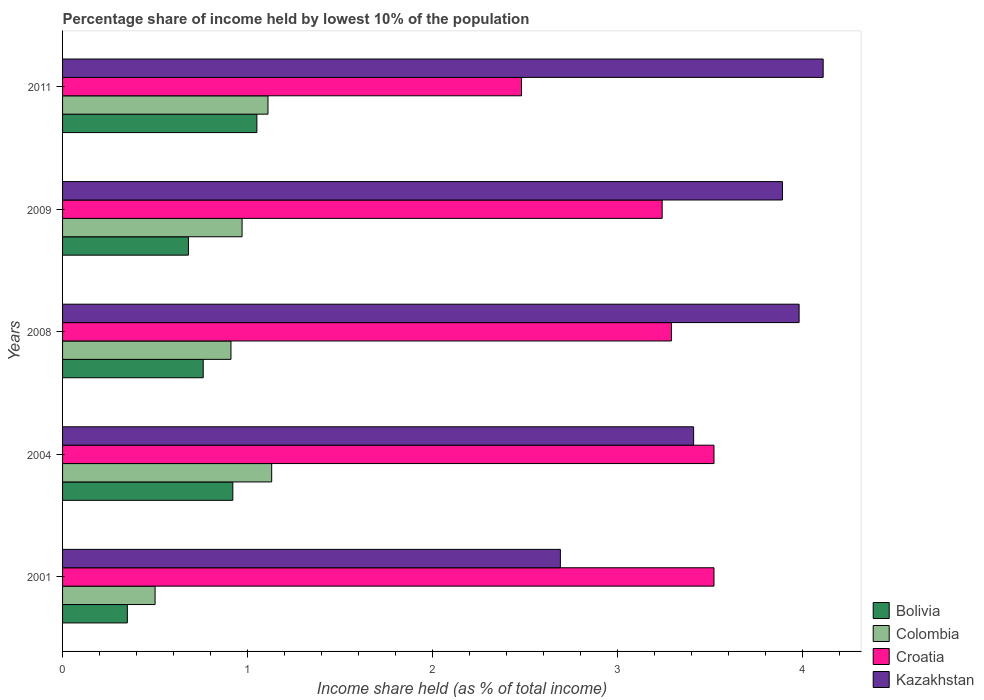How many different coloured bars are there?
Your answer should be very brief. 4. How many groups of bars are there?
Offer a terse response. 5. Are the number of bars on each tick of the Y-axis equal?
Your answer should be compact. Yes. How many bars are there on the 1st tick from the top?
Provide a short and direct response. 4. How many bars are there on the 2nd tick from the bottom?
Provide a succinct answer. 4. What is the label of the 5th group of bars from the top?
Your answer should be compact. 2001. In how many cases, is the number of bars for a given year not equal to the number of legend labels?
Keep it short and to the point. 0. Across all years, what is the minimum percentage share of income held by lowest 10% of the population in Kazakhstan?
Ensure brevity in your answer.  2.69. In which year was the percentage share of income held by lowest 10% of the population in Bolivia maximum?
Offer a terse response. 2011. In which year was the percentage share of income held by lowest 10% of the population in Colombia minimum?
Your answer should be compact. 2001. What is the total percentage share of income held by lowest 10% of the population in Bolivia in the graph?
Make the answer very short. 3.76. What is the difference between the percentage share of income held by lowest 10% of the population in Croatia in 2004 and that in 2009?
Offer a very short reply. 0.28. What is the difference between the percentage share of income held by lowest 10% of the population in Colombia in 2009 and the percentage share of income held by lowest 10% of the population in Kazakhstan in 2008?
Make the answer very short. -3.01. What is the average percentage share of income held by lowest 10% of the population in Kazakhstan per year?
Make the answer very short. 3.62. In the year 2011, what is the difference between the percentage share of income held by lowest 10% of the population in Croatia and percentage share of income held by lowest 10% of the population in Colombia?
Give a very brief answer. 1.37. What is the ratio of the percentage share of income held by lowest 10% of the population in Bolivia in 2004 to that in 2009?
Your answer should be very brief. 1.35. Is the percentage share of income held by lowest 10% of the population in Colombia in 2004 less than that in 2008?
Provide a succinct answer. No. Is the difference between the percentage share of income held by lowest 10% of the population in Croatia in 2001 and 2008 greater than the difference between the percentage share of income held by lowest 10% of the population in Colombia in 2001 and 2008?
Keep it short and to the point. Yes. What is the difference between the highest and the lowest percentage share of income held by lowest 10% of the population in Kazakhstan?
Your answer should be compact. 1.42. Is it the case that in every year, the sum of the percentage share of income held by lowest 10% of the population in Croatia and percentage share of income held by lowest 10% of the population in Bolivia is greater than the sum of percentage share of income held by lowest 10% of the population in Kazakhstan and percentage share of income held by lowest 10% of the population in Colombia?
Make the answer very short. Yes. What does the 4th bar from the top in 2001 represents?
Your answer should be compact. Bolivia. What does the 4th bar from the bottom in 2004 represents?
Offer a very short reply. Kazakhstan. Is it the case that in every year, the sum of the percentage share of income held by lowest 10% of the population in Croatia and percentage share of income held by lowest 10% of the population in Colombia is greater than the percentage share of income held by lowest 10% of the population in Kazakhstan?
Provide a short and direct response. No. Does the graph contain any zero values?
Make the answer very short. No. How many legend labels are there?
Offer a very short reply. 4. What is the title of the graph?
Make the answer very short. Percentage share of income held by lowest 10% of the population. What is the label or title of the X-axis?
Provide a succinct answer. Income share held (as % of total income). What is the label or title of the Y-axis?
Your answer should be compact. Years. What is the Income share held (as % of total income) of Croatia in 2001?
Offer a terse response. 3.52. What is the Income share held (as % of total income) in Kazakhstan in 2001?
Keep it short and to the point. 2.69. What is the Income share held (as % of total income) of Bolivia in 2004?
Keep it short and to the point. 0.92. What is the Income share held (as % of total income) in Colombia in 2004?
Your answer should be very brief. 1.13. What is the Income share held (as % of total income) in Croatia in 2004?
Provide a succinct answer. 3.52. What is the Income share held (as % of total income) of Kazakhstan in 2004?
Your response must be concise. 3.41. What is the Income share held (as % of total income) of Bolivia in 2008?
Provide a short and direct response. 0.76. What is the Income share held (as % of total income) in Colombia in 2008?
Your answer should be very brief. 0.91. What is the Income share held (as % of total income) of Croatia in 2008?
Ensure brevity in your answer.  3.29. What is the Income share held (as % of total income) in Kazakhstan in 2008?
Your response must be concise. 3.98. What is the Income share held (as % of total income) of Bolivia in 2009?
Your answer should be very brief. 0.68. What is the Income share held (as % of total income) of Colombia in 2009?
Your answer should be compact. 0.97. What is the Income share held (as % of total income) of Croatia in 2009?
Offer a very short reply. 3.24. What is the Income share held (as % of total income) in Kazakhstan in 2009?
Make the answer very short. 3.89. What is the Income share held (as % of total income) in Colombia in 2011?
Ensure brevity in your answer.  1.11. What is the Income share held (as % of total income) of Croatia in 2011?
Your answer should be compact. 2.48. What is the Income share held (as % of total income) of Kazakhstan in 2011?
Offer a very short reply. 4.11. Across all years, what is the maximum Income share held (as % of total income) of Colombia?
Offer a terse response. 1.13. Across all years, what is the maximum Income share held (as % of total income) of Croatia?
Make the answer very short. 3.52. Across all years, what is the maximum Income share held (as % of total income) of Kazakhstan?
Your response must be concise. 4.11. Across all years, what is the minimum Income share held (as % of total income) of Colombia?
Ensure brevity in your answer.  0.5. Across all years, what is the minimum Income share held (as % of total income) of Croatia?
Ensure brevity in your answer.  2.48. Across all years, what is the minimum Income share held (as % of total income) in Kazakhstan?
Keep it short and to the point. 2.69. What is the total Income share held (as % of total income) of Bolivia in the graph?
Give a very brief answer. 3.76. What is the total Income share held (as % of total income) in Colombia in the graph?
Ensure brevity in your answer.  4.62. What is the total Income share held (as % of total income) of Croatia in the graph?
Offer a terse response. 16.05. What is the total Income share held (as % of total income) in Kazakhstan in the graph?
Your answer should be very brief. 18.08. What is the difference between the Income share held (as % of total income) in Bolivia in 2001 and that in 2004?
Provide a short and direct response. -0.57. What is the difference between the Income share held (as % of total income) of Colombia in 2001 and that in 2004?
Your response must be concise. -0.63. What is the difference between the Income share held (as % of total income) of Kazakhstan in 2001 and that in 2004?
Your answer should be very brief. -0.72. What is the difference between the Income share held (as % of total income) in Bolivia in 2001 and that in 2008?
Offer a very short reply. -0.41. What is the difference between the Income share held (as % of total income) in Colombia in 2001 and that in 2008?
Ensure brevity in your answer.  -0.41. What is the difference between the Income share held (as % of total income) of Croatia in 2001 and that in 2008?
Your answer should be very brief. 0.23. What is the difference between the Income share held (as % of total income) of Kazakhstan in 2001 and that in 2008?
Your answer should be very brief. -1.29. What is the difference between the Income share held (as % of total income) of Bolivia in 2001 and that in 2009?
Your answer should be compact. -0.33. What is the difference between the Income share held (as % of total income) in Colombia in 2001 and that in 2009?
Keep it short and to the point. -0.47. What is the difference between the Income share held (as % of total income) in Croatia in 2001 and that in 2009?
Ensure brevity in your answer.  0.28. What is the difference between the Income share held (as % of total income) in Kazakhstan in 2001 and that in 2009?
Make the answer very short. -1.2. What is the difference between the Income share held (as % of total income) of Colombia in 2001 and that in 2011?
Offer a terse response. -0.61. What is the difference between the Income share held (as % of total income) in Croatia in 2001 and that in 2011?
Your response must be concise. 1.04. What is the difference between the Income share held (as % of total income) of Kazakhstan in 2001 and that in 2011?
Your answer should be compact. -1.42. What is the difference between the Income share held (as % of total income) of Bolivia in 2004 and that in 2008?
Offer a terse response. 0.16. What is the difference between the Income share held (as % of total income) in Colombia in 2004 and that in 2008?
Make the answer very short. 0.22. What is the difference between the Income share held (as % of total income) in Croatia in 2004 and that in 2008?
Make the answer very short. 0.23. What is the difference between the Income share held (as % of total income) of Kazakhstan in 2004 and that in 2008?
Your answer should be compact. -0.57. What is the difference between the Income share held (as % of total income) of Bolivia in 2004 and that in 2009?
Your answer should be very brief. 0.24. What is the difference between the Income share held (as % of total income) of Colombia in 2004 and that in 2009?
Ensure brevity in your answer.  0.16. What is the difference between the Income share held (as % of total income) of Croatia in 2004 and that in 2009?
Provide a succinct answer. 0.28. What is the difference between the Income share held (as % of total income) in Kazakhstan in 2004 and that in 2009?
Offer a very short reply. -0.48. What is the difference between the Income share held (as % of total income) in Bolivia in 2004 and that in 2011?
Your response must be concise. -0.13. What is the difference between the Income share held (as % of total income) in Colombia in 2004 and that in 2011?
Your answer should be compact. 0.02. What is the difference between the Income share held (as % of total income) of Croatia in 2004 and that in 2011?
Ensure brevity in your answer.  1.04. What is the difference between the Income share held (as % of total income) of Bolivia in 2008 and that in 2009?
Provide a short and direct response. 0.08. What is the difference between the Income share held (as % of total income) in Colombia in 2008 and that in 2009?
Your answer should be very brief. -0.06. What is the difference between the Income share held (as % of total income) of Kazakhstan in 2008 and that in 2009?
Your answer should be very brief. 0.09. What is the difference between the Income share held (as % of total income) of Bolivia in 2008 and that in 2011?
Offer a very short reply. -0.29. What is the difference between the Income share held (as % of total income) of Colombia in 2008 and that in 2011?
Keep it short and to the point. -0.2. What is the difference between the Income share held (as % of total income) of Croatia in 2008 and that in 2011?
Your answer should be compact. 0.81. What is the difference between the Income share held (as % of total income) of Kazakhstan in 2008 and that in 2011?
Offer a terse response. -0.13. What is the difference between the Income share held (as % of total income) in Bolivia in 2009 and that in 2011?
Give a very brief answer. -0.37. What is the difference between the Income share held (as % of total income) in Colombia in 2009 and that in 2011?
Your answer should be compact. -0.14. What is the difference between the Income share held (as % of total income) of Croatia in 2009 and that in 2011?
Your answer should be very brief. 0.76. What is the difference between the Income share held (as % of total income) in Kazakhstan in 2009 and that in 2011?
Provide a succinct answer. -0.22. What is the difference between the Income share held (as % of total income) in Bolivia in 2001 and the Income share held (as % of total income) in Colombia in 2004?
Make the answer very short. -0.78. What is the difference between the Income share held (as % of total income) in Bolivia in 2001 and the Income share held (as % of total income) in Croatia in 2004?
Give a very brief answer. -3.17. What is the difference between the Income share held (as % of total income) of Bolivia in 2001 and the Income share held (as % of total income) of Kazakhstan in 2004?
Your response must be concise. -3.06. What is the difference between the Income share held (as % of total income) in Colombia in 2001 and the Income share held (as % of total income) in Croatia in 2004?
Make the answer very short. -3.02. What is the difference between the Income share held (as % of total income) in Colombia in 2001 and the Income share held (as % of total income) in Kazakhstan in 2004?
Make the answer very short. -2.91. What is the difference between the Income share held (as % of total income) of Croatia in 2001 and the Income share held (as % of total income) of Kazakhstan in 2004?
Make the answer very short. 0.11. What is the difference between the Income share held (as % of total income) of Bolivia in 2001 and the Income share held (as % of total income) of Colombia in 2008?
Your response must be concise. -0.56. What is the difference between the Income share held (as % of total income) in Bolivia in 2001 and the Income share held (as % of total income) in Croatia in 2008?
Offer a very short reply. -2.94. What is the difference between the Income share held (as % of total income) in Bolivia in 2001 and the Income share held (as % of total income) in Kazakhstan in 2008?
Your answer should be compact. -3.63. What is the difference between the Income share held (as % of total income) of Colombia in 2001 and the Income share held (as % of total income) of Croatia in 2008?
Your answer should be compact. -2.79. What is the difference between the Income share held (as % of total income) of Colombia in 2001 and the Income share held (as % of total income) of Kazakhstan in 2008?
Your response must be concise. -3.48. What is the difference between the Income share held (as % of total income) of Croatia in 2001 and the Income share held (as % of total income) of Kazakhstan in 2008?
Keep it short and to the point. -0.46. What is the difference between the Income share held (as % of total income) in Bolivia in 2001 and the Income share held (as % of total income) in Colombia in 2009?
Your response must be concise. -0.62. What is the difference between the Income share held (as % of total income) of Bolivia in 2001 and the Income share held (as % of total income) of Croatia in 2009?
Give a very brief answer. -2.89. What is the difference between the Income share held (as % of total income) in Bolivia in 2001 and the Income share held (as % of total income) in Kazakhstan in 2009?
Provide a short and direct response. -3.54. What is the difference between the Income share held (as % of total income) of Colombia in 2001 and the Income share held (as % of total income) of Croatia in 2009?
Give a very brief answer. -2.74. What is the difference between the Income share held (as % of total income) in Colombia in 2001 and the Income share held (as % of total income) in Kazakhstan in 2009?
Your response must be concise. -3.39. What is the difference between the Income share held (as % of total income) in Croatia in 2001 and the Income share held (as % of total income) in Kazakhstan in 2009?
Offer a very short reply. -0.37. What is the difference between the Income share held (as % of total income) of Bolivia in 2001 and the Income share held (as % of total income) of Colombia in 2011?
Make the answer very short. -0.76. What is the difference between the Income share held (as % of total income) in Bolivia in 2001 and the Income share held (as % of total income) in Croatia in 2011?
Keep it short and to the point. -2.13. What is the difference between the Income share held (as % of total income) of Bolivia in 2001 and the Income share held (as % of total income) of Kazakhstan in 2011?
Keep it short and to the point. -3.76. What is the difference between the Income share held (as % of total income) in Colombia in 2001 and the Income share held (as % of total income) in Croatia in 2011?
Your response must be concise. -1.98. What is the difference between the Income share held (as % of total income) in Colombia in 2001 and the Income share held (as % of total income) in Kazakhstan in 2011?
Make the answer very short. -3.61. What is the difference between the Income share held (as % of total income) in Croatia in 2001 and the Income share held (as % of total income) in Kazakhstan in 2011?
Offer a terse response. -0.59. What is the difference between the Income share held (as % of total income) of Bolivia in 2004 and the Income share held (as % of total income) of Colombia in 2008?
Offer a terse response. 0.01. What is the difference between the Income share held (as % of total income) in Bolivia in 2004 and the Income share held (as % of total income) in Croatia in 2008?
Provide a succinct answer. -2.37. What is the difference between the Income share held (as % of total income) of Bolivia in 2004 and the Income share held (as % of total income) of Kazakhstan in 2008?
Make the answer very short. -3.06. What is the difference between the Income share held (as % of total income) of Colombia in 2004 and the Income share held (as % of total income) of Croatia in 2008?
Provide a succinct answer. -2.16. What is the difference between the Income share held (as % of total income) of Colombia in 2004 and the Income share held (as % of total income) of Kazakhstan in 2008?
Your response must be concise. -2.85. What is the difference between the Income share held (as % of total income) in Croatia in 2004 and the Income share held (as % of total income) in Kazakhstan in 2008?
Offer a terse response. -0.46. What is the difference between the Income share held (as % of total income) in Bolivia in 2004 and the Income share held (as % of total income) in Colombia in 2009?
Provide a succinct answer. -0.05. What is the difference between the Income share held (as % of total income) of Bolivia in 2004 and the Income share held (as % of total income) of Croatia in 2009?
Give a very brief answer. -2.32. What is the difference between the Income share held (as % of total income) in Bolivia in 2004 and the Income share held (as % of total income) in Kazakhstan in 2009?
Offer a terse response. -2.97. What is the difference between the Income share held (as % of total income) of Colombia in 2004 and the Income share held (as % of total income) of Croatia in 2009?
Your response must be concise. -2.11. What is the difference between the Income share held (as % of total income) in Colombia in 2004 and the Income share held (as % of total income) in Kazakhstan in 2009?
Make the answer very short. -2.76. What is the difference between the Income share held (as % of total income) in Croatia in 2004 and the Income share held (as % of total income) in Kazakhstan in 2009?
Provide a short and direct response. -0.37. What is the difference between the Income share held (as % of total income) of Bolivia in 2004 and the Income share held (as % of total income) of Colombia in 2011?
Make the answer very short. -0.19. What is the difference between the Income share held (as % of total income) in Bolivia in 2004 and the Income share held (as % of total income) in Croatia in 2011?
Offer a terse response. -1.56. What is the difference between the Income share held (as % of total income) in Bolivia in 2004 and the Income share held (as % of total income) in Kazakhstan in 2011?
Ensure brevity in your answer.  -3.19. What is the difference between the Income share held (as % of total income) of Colombia in 2004 and the Income share held (as % of total income) of Croatia in 2011?
Your response must be concise. -1.35. What is the difference between the Income share held (as % of total income) in Colombia in 2004 and the Income share held (as % of total income) in Kazakhstan in 2011?
Keep it short and to the point. -2.98. What is the difference between the Income share held (as % of total income) of Croatia in 2004 and the Income share held (as % of total income) of Kazakhstan in 2011?
Keep it short and to the point. -0.59. What is the difference between the Income share held (as % of total income) of Bolivia in 2008 and the Income share held (as % of total income) of Colombia in 2009?
Provide a short and direct response. -0.21. What is the difference between the Income share held (as % of total income) of Bolivia in 2008 and the Income share held (as % of total income) of Croatia in 2009?
Offer a very short reply. -2.48. What is the difference between the Income share held (as % of total income) in Bolivia in 2008 and the Income share held (as % of total income) in Kazakhstan in 2009?
Provide a succinct answer. -3.13. What is the difference between the Income share held (as % of total income) of Colombia in 2008 and the Income share held (as % of total income) of Croatia in 2009?
Give a very brief answer. -2.33. What is the difference between the Income share held (as % of total income) in Colombia in 2008 and the Income share held (as % of total income) in Kazakhstan in 2009?
Offer a very short reply. -2.98. What is the difference between the Income share held (as % of total income) in Bolivia in 2008 and the Income share held (as % of total income) in Colombia in 2011?
Provide a short and direct response. -0.35. What is the difference between the Income share held (as % of total income) in Bolivia in 2008 and the Income share held (as % of total income) in Croatia in 2011?
Your answer should be very brief. -1.72. What is the difference between the Income share held (as % of total income) of Bolivia in 2008 and the Income share held (as % of total income) of Kazakhstan in 2011?
Your answer should be compact. -3.35. What is the difference between the Income share held (as % of total income) of Colombia in 2008 and the Income share held (as % of total income) of Croatia in 2011?
Your answer should be compact. -1.57. What is the difference between the Income share held (as % of total income) of Croatia in 2008 and the Income share held (as % of total income) of Kazakhstan in 2011?
Give a very brief answer. -0.82. What is the difference between the Income share held (as % of total income) in Bolivia in 2009 and the Income share held (as % of total income) in Colombia in 2011?
Provide a succinct answer. -0.43. What is the difference between the Income share held (as % of total income) of Bolivia in 2009 and the Income share held (as % of total income) of Kazakhstan in 2011?
Provide a succinct answer. -3.43. What is the difference between the Income share held (as % of total income) in Colombia in 2009 and the Income share held (as % of total income) in Croatia in 2011?
Give a very brief answer. -1.51. What is the difference between the Income share held (as % of total income) of Colombia in 2009 and the Income share held (as % of total income) of Kazakhstan in 2011?
Your answer should be compact. -3.14. What is the difference between the Income share held (as % of total income) in Croatia in 2009 and the Income share held (as % of total income) in Kazakhstan in 2011?
Ensure brevity in your answer.  -0.87. What is the average Income share held (as % of total income) in Bolivia per year?
Give a very brief answer. 0.75. What is the average Income share held (as % of total income) of Colombia per year?
Offer a terse response. 0.92. What is the average Income share held (as % of total income) of Croatia per year?
Ensure brevity in your answer.  3.21. What is the average Income share held (as % of total income) in Kazakhstan per year?
Offer a terse response. 3.62. In the year 2001, what is the difference between the Income share held (as % of total income) of Bolivia and Income share held (as % of total income) of Colombia?
Make the answer very short. -0.15. In the year 2001, what is the difference between the Income share held (as % of total income) in Bolivia and Income share held (as % of total income) in Croatia?
Your answer should be compact. -3.17. In the year 2001, what is the difference between the Income share held (as % of total income) in Bolivia and Income share held (as % of total income) in Kazakhstan?
Provide a succinct answer. -2.34. In the year 2001, what is the difference between the Income share held (as % of total income) in Colombia and Income share held (as % of total income) in Croatia?
Offer a very short reply. -3.02. In the year 2001, what is the difference between the Income share held (as % of total income) of Colombia and Income share held (as % of total income) of Kazakhstan?
Provide a short and direct response. -2.19. In the year 2001, what is the difference between the Income share held (as % of total income) of Croatia and Income share held (as % of total income) of Kazakhstan?
Make the answer very short. 0.83. In the year 2004, what is the difference between the Income share held (as % of total income) of Bolivia and Income share held (as % of total income) of Colombia?
Ensure brevity in your answer.  -0.21. In the year 2004, what is the difference between the Income share held (as % of total income) of Bolivia and Income share held (as % of total income) of Croatia?
Ensure brevity in your answer.  -2.6. In the year 2004, what is the difference between the Income share held (as % of total income) of Bolivia and Income share held (as % of total income) of Kazakhstan?
Make the answer very short. -2.49. In the year 2004, what is the difference between the Income share held (as % of total income) in Colombia and Income share held (as % of total income) in Croatia?
Offer a terse response. -2.39. In the year 2004, what is the difference between the Income share held (as % of total income) of Colombia and Income share held (as % of total income) of Kazakhstan?
Provide a short and direct response. -2.28. In the year 2004, what is the difference between the Income share held (as % of total income) of Croatia and Income share held (as % of total income) of Kazakhstan?
Give a very brief answer. 0.11. In the year 2008, what is the difference between the Income share held (as % of total income) in Bolivia and Income share held (as % of total income) in Colombia?
Your answer should be very brief. -0.15. In the year 2008, what is the difference between the Income share held (as % of total income) of Bolivia and Income share held (as % of total income) of Croatia?
Your response must be concise. -2.53. In the year 2008, what is the difference between the Income share held (as % of total income) in Bolivia and Income share held (as % of total income) in Kazakhstan?
Your response must be concise. -3.22. In the year 2008, what is the difference between the Income share held (as % of total income) in Colombia and Income share held (as % of total income) in Croatia?
Make the answer very short. -2.38. In the year 2008, what is the difference between the Income share held (as % of total income) of Colombia and Income share held (as % of total income) of Kazakhstan?
Your answer should be compact. -3.07. In the year 2008, what is the difference between the Income share held (as % of total income) in Croatia and Income share held (as % of total income) in Kazakhstan?
Your answer should be very brief. -0.69. In the year 2009, what is the difference between the Income share held (as % of total income) in Bolivia and Income share held (as % of total income) in Colombia?
Keep it short and to the point. -0.29. In the year 2009, what is the difference between the Income share held (as % of total income) in Bolivia and Income share held (as % of total income) in Croatia?
Your answer should be compact. -2.56. In the year 2009, what is the difference between the Income share held (as % of total income) of Bolivia and Income share held (as % of total income) of Kazakhstan?
Make the answer very short. -3.21. In the year 2009, what is the difference between the Income share held (as % of total income) of Colombia and Income share held (as % of total income) of Croatia?
Your answer should be very brief. -2.27. In the year 2009, what is the difference between the Income share held (as % of total income) of Colombia and Income share held (as % of total income) of Kazakhstan?
Make the answer very short. -2.92. In the year 2009, what is the difference between the Income share held (as % of total income) in Croatia and Income share held (as % of total income) in Kazakhstan?
Provide a succinct answer. -0.65. In the year 2011, what is the difference between the Income share held (as % of total income) of Bolivia and Income share held (as % of total income) of Colombia?
Your answer should be compact. -0.06. In the year 2011, what is the difference between the Income share held (as % of total income) of Bolivia and Income share held (as % of total income) of Croatia?
Your answer should be compact. -1.43. In the year 2011, what is the difference between the Income share held (as % of total income) in Bolivia and Income share held (as % of total income) in Kazakhstan?
Give a very brief answer. -3.06. In the year 2011, what is the difference between the Income share held (as % of total income) in Colombia and Income share held (as % of total income) in Croatia?
Make the answer very short. -1.37. In the year 2011, what is the difference between the Income share held (as % of total income) of Croatia and Income share held (as % of total income) of Kazakhstan?
Your response must be concise. -1.63. What is the ratio of the Income share held (as % of total income) in Bolivia in 2001 to that in 2004?
Offer a terse response. 0.38. What is the ratio of the Income share held (as % of total income) in Colombia in 2001 to that in 2004?
Provide a succinct answer. 0.44. What is the ratio of the Income share held (as % of total income) in Croatia in 2001 to that in 2004?
Offer a terse response. 1. What is the ratio of the Income share held (as % of total income) of Kazakhstan in 2001 to that in 2004?
Provide a short and direct response. 0.79. What is the ratio of the Income share held (as % of total income) in Bolivia in 2001 to that in 2008?
Keep it short and to the point. 0.46. What is the ratio of the Income share held (as % of total income) in Colombia in 2001 to that in 2008?
Your answer should be compact. 0.55. What is the ratio of the Income share held (as % of total income) of Croatia in 2001 to that in 2008?
Offer a very short reply. 1.07. What is the ratio of the Income share held (as % of total income) in Kazakhstan in 2001 to that in 2008?
Your response must be concise. 0.68. What is the ratio of the Income share held (as % of total income) in Bolivia in 2001 to that in 2009?
Your answer should be compact. 0.51. What is the ratio of the Income share held (as % of total income) of Colombia in 2001 to that in 2009?
Your answer should be compact. 0.52. What is the ratio of the Income share held (as % of total income) in Croatia in 2001 to that in 2009?
Offer a terse response. 1.09. What is the ratio of the Income share held (as % of total income) of Kazakhstan in 2001 to that in 2009?
Give a very brief answer. 0.69. What is the ratio of the Income share held (as % of total income) of Colombia in 2001 to that in 2011?
Give a very brief answer. 0.45. What is the ratio of the Income share held (as % of total income) in Croatia in 2001 to that in 2011?
Keep it short and to the point. 1.42. What is the ratio of the Income share held (as % of total income) in Kazakhstan in 2001 to that in 2011?
Offer a very short reply. 0.65. What is the ratio of the Income share held (as % of total income) in Bolivia in 2004 to that in 2008?
Offer a very short reply. 1.21. What is the ratio of the Income share held (as % of total income) of Colombia in 2004 to that in 2008?
Give a very brief answer. 1.24. What is the ratio of the Income share held (as % of total income) in Croatia in 2004 to that in 2008?
Keep it short and to the point. 1.07. What is the ratio of the Income share held (as % of total income) in Kazakhstan in 2004 to that in 2008?
Your response must be concise. 0.86. What is the ratio of the Income share held (as % of total income) of Bolivia in 2004 to that in 2009?
Make the answer very short. 1.35. What is the ratio of the Income share held (as % of total income) in Colombia in 2004 to that in 2009?
Give a very brief answer. 1.16. What is the ratio of the Income share held (as % of total income) of Croatia in 2004 to that in 2009?
Your response must be concise. 1.09. What is the ratio of the Income share held (as % of total income) of Kazakhstan in 2004 to that in 2009?
Your answer should be very brief. 0.88. What is the ratio of the Income share held (as % of total income) in Bolivia in 2004 to that in 2011?
Your answer should be very brief. 0.88. What is the ratio of the Income share held (as % of total income) in Colombia in 2004 to that in 2011?
Your response must be concise. 1.02. What is the ratio of the Income share held (as % of total income) in Croatia in 2004 to that in 2011?
Your answer should be very brief. 1.42. What is the ratio of the Income share held (as % of total income) of Kazakhstan in 2004 to that in 2011?
Ensure brevity in your answer.  0.83. What is the ratio of the Income share held (as % of total income) in Bolivia in 2008 to that in 2009?
Your answer should be compact. 1.12. What is the ratio of the Income share held (as % of total income) in Colombia in 2008 to that in 2009?
Give a very brief answer. 0.94. What is the ratio of the Income share held (as % of total income) in Croatia in 2008 to that in 2009?
Offer a very short reply. 1.02. What is the ratio of the Income share held (as % of total income) of Kazakhstan in 2008 to that in 2009?
Offer a terse response. 1.02. What is the ratio of the Income share held (as % of total income) in Bolivia in 2008 to that in 2011?
Make the answer very short. 0.72. What is the ratio of the Income share held (as % of total income) in Colombia in 2008 to that in 2011?
Your answer should be compact. 0.82. What is the ratio of the Income share held (as % of total income) of Croatia in 2008 to that in 2011?
Ensure brevity in your answer.  1.33. What is the ratio of the Income share held (as % of total income) of Kazakhstan in 2008 to that in 2011?
Provide a succinct answer. 0.97. What is the ratio of the Income share held (as % of total income) of Bolivia in 2009 to that in 2011?
Offer a terse response. 0.65. What is the ratio of the Income share held (as % of total income) in Colombia in 2009 to that in 2011?
Offer a terse response. 0.87. What is the ratio of the Income share held (as % of total income) in Croatia in 2009 to that in 2011?
Provide a short and direct response. 1.31. What is the ratio of the Income share held (as % of total income) of Kazakhstan in 2009 to that in 2011?
Your answer should be compact. 0.95. What is the difference between the highest and the second highest Income share held (as % of total income) in Bolivia?
Your answer should be compact. 0.13. What is the difference between the highest and the second highest Income share held (as % of total income) in Croatia?
Keep it short and to the point. 0. What is the difference between the highest and the second highest Income share held (as % of total income) in Kazakhstan?
Provide a succinct answer. 0.13. What is the difference between the highest and the lowest Income share held (as % of total income) of Colombia?
Provide a short and direct response. 0.63. What is the difference between the highest and the lowest Income share held (as % of total income) in Croatia?
Provide a succinct answer. 1.04. What is the difference between the highest and the lowest Income share held (as % of total income) in Kazakhstan?
Give a very brief answer. 1.42. 